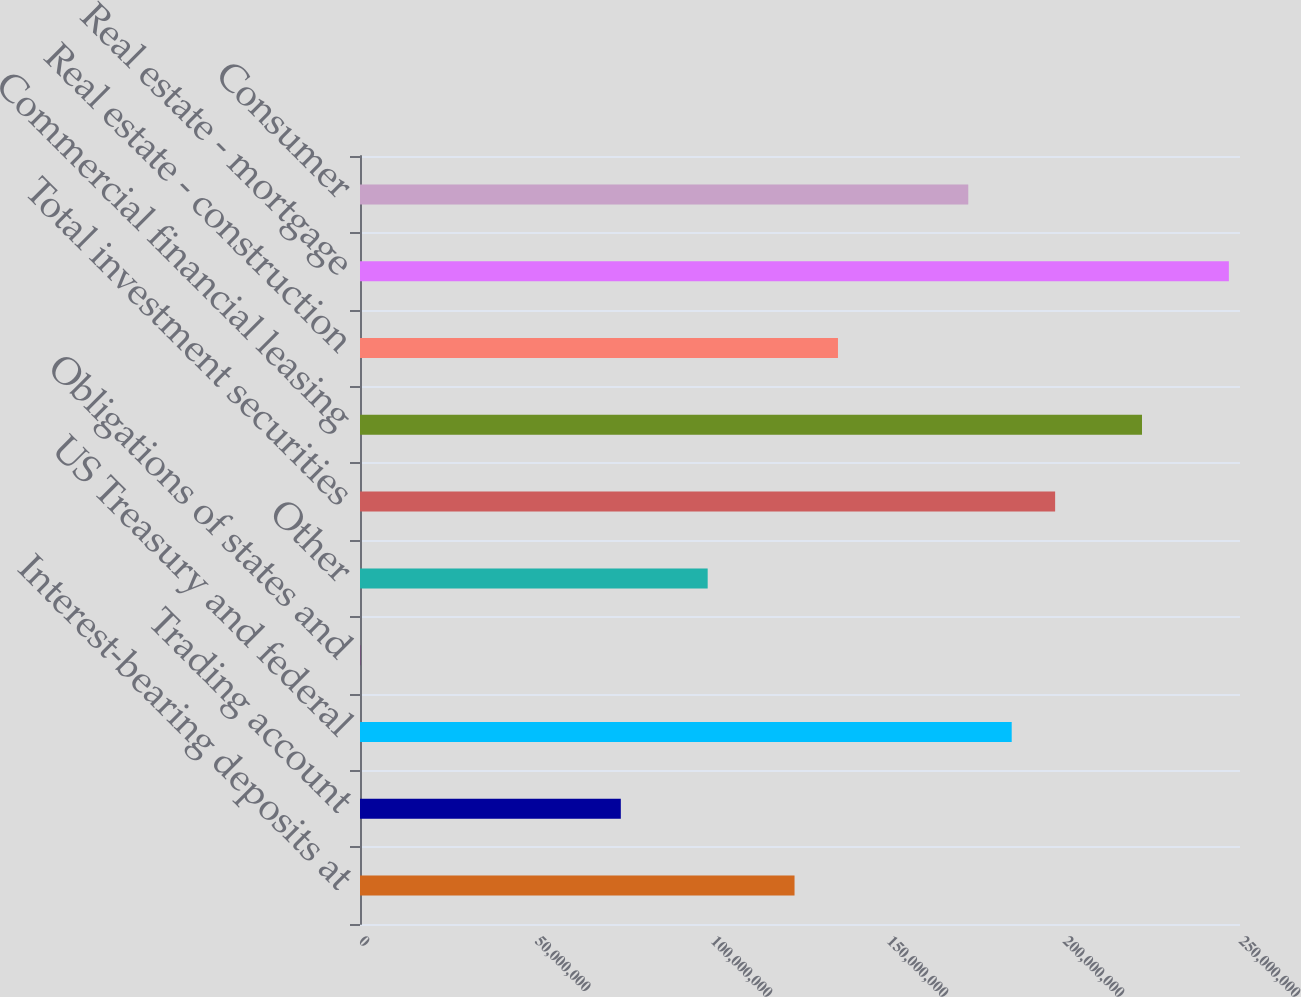Convert chart. <chart><loc_0><loc_0><loc_500><loc_500><bar_chart><fcel>Interest-bearing deposits at<fcel>Trading account<fcel>US Treasury and federal<fcel>Obligations of states and<fcel>Other<fcel>Total investment securities<fcel>Commercial financial leasing<fcel>Real estate - construction<fcel>Real estate - mortgage<fcel>Consumer<nl><fcel>1.23449e+08<fcel>7.40953e+07<fcel>1.85142e+08<fcel>64499<fcel>9.87723e+07<fcel>1.9748e+08<fcel>2.22157e+08<fcel>1.35788e+08<fcel>2.46834e+08<fcel>1.72803e+08<nl></chart> 